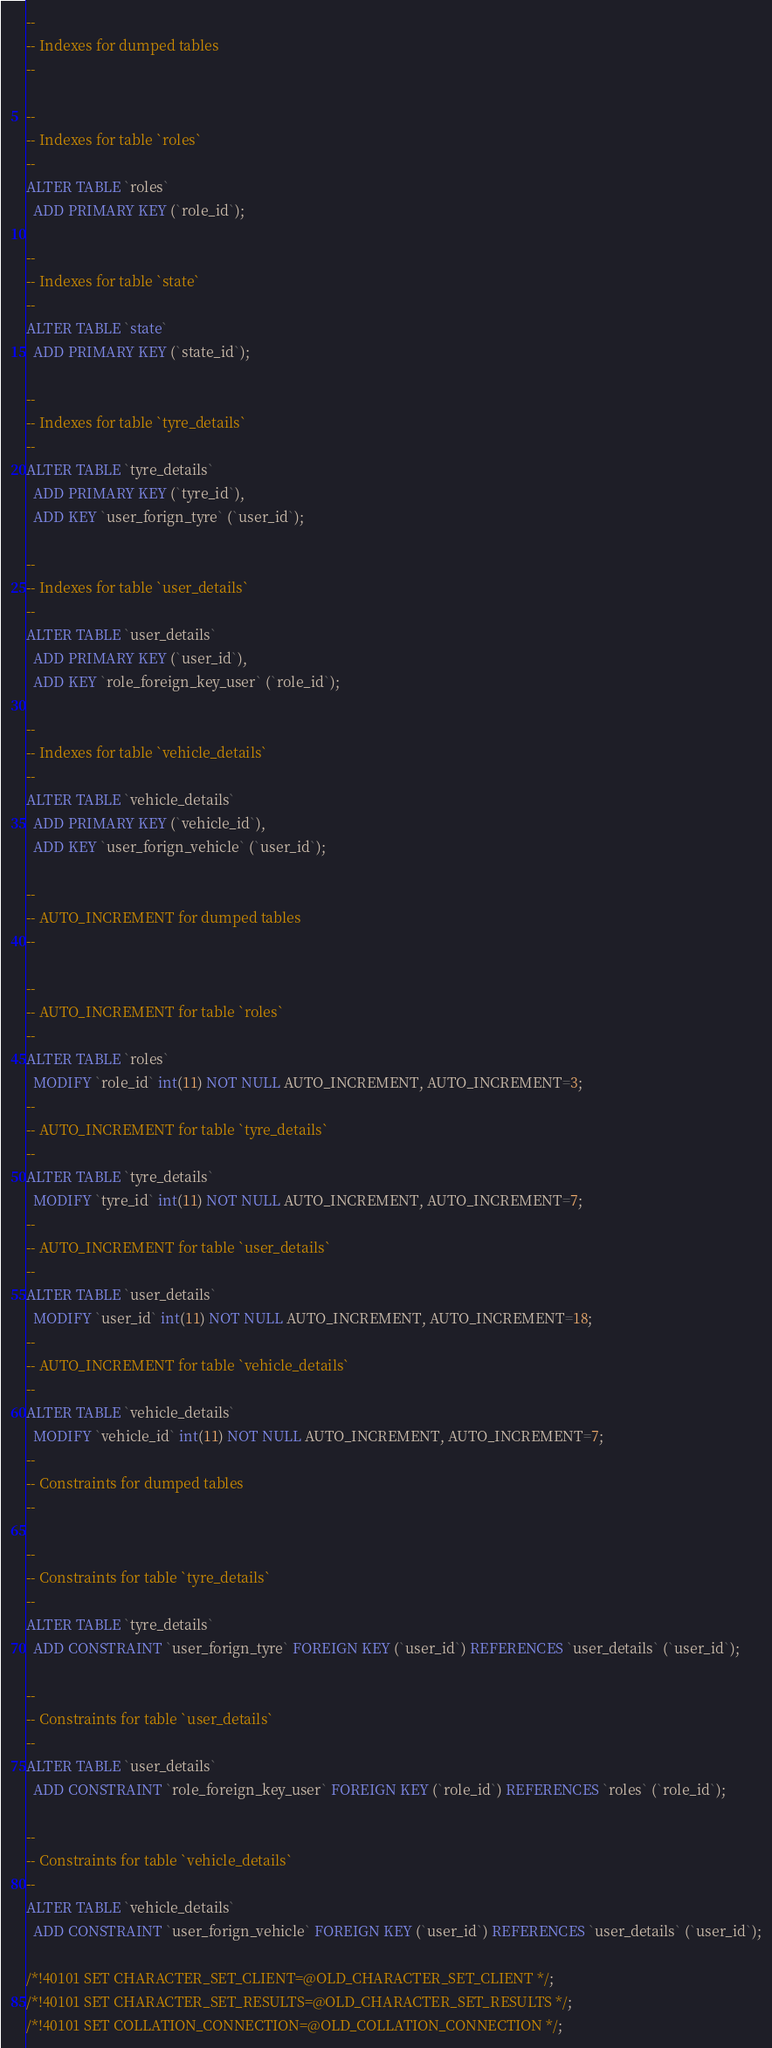Convert code to text. <code><loc_0><loc_0><loc_500><loc_500><_SQL_>--
-- Indexes for dumped tables
--

--
-- Indexes for table `roles`
--
ALTER TABLE `roles`
  ADD PRIMARY KEY (`role_id`);

--
-- Indexes for table `state`
--
ALTER TABLE `state`
  ADD PRIMARY KEY (`state_id`);

--
-- Indexes for table `tyre_details`
--
ALTER TABLE `tyre_details`
  ADD PRIMARY KEY (`tyre_id`),
  ADD KEY `user_forign_tyre` (`user_id`);

--
-- Indexes for table `user_details`
--
ALTER TABLE `user_details`
  ADD PRIMARY KEY (`user_id`),
  ADD KEY `role_foreign_key_user` (`role_id`);

--
-- Indexes for table `vehicle_details`
--
ALTER TABLE `vehicle_details`
  ADD PRIMARY KEY (`vehicle_id`),
  ADD KEY `user_forign_vehicle` (`user_id`);

--
-- AUTO_INCREMENT for dumped tables
--

--
-- AUTO_INCREMENT for table `roles`
--
ALTER TABLE `roles`
  MODIFY `role_id` int(11) NOT NULL AUTO_INCREMENT, AUTO_INCREMENT=3;
--
-- AUTO_INCREMENT for table `tyre_details`
--
ALTER TABLE `tyre_details`
  MODIFY `tyre_id` int(11) NOT NULL AUTO_INCREMENT, AUTO_INCREMENT=7;
--
-- AUTO_INCREMENT for table `user_details`
--
ALTER TABLE `user_details`
  MODIFY `user_id` int(11) NOT NULL AUTO_INCREMENT, AUTO_INCREMENT=18;
--
-- AUTO_INCREMENT for table `vehicle_details`
--
ALTER TABLE `vehicle_details`
  MODIFY `vehicle_id` int(11) NOT NULL AUTO_INCREMENT, AUTO_INCREMENT=7;
--
-- Constraints for dumped tables
--

--
-- Constraints for table `tyre_details`
--
ALTER TABLE `tyre_details`
  ADD CONSTRAINT `user_forign_tyre` FOREIGN KEY (`user_id`) REFERENCES `user_details` (`user_id`);

--
-- Constraints for table `user_details`
--
ALTER TABLE `user_details`
  ADD CONSTRAINT `role_foreign_key_user` FOREIGN KEY (`role_id`) REFERENCES `roles` (`role_id`);

--
-- Constraints for table `vehicle_details`
--
ALTER TABLE `vehicle_details`
  ADD CONSTRAINT `user_forign_vehicle` FOREIGN KEY (`user_id`) REFERENCES `user_details` (`user_id`);

/*!40101 SET CHARACTER_SET_CLIENT=@OLD_CHARACTER_SET_CLIENT */;
/*!40101 SET CHARACTER_SET_RESULTS=@OLD_CHARACTER_SET_RESULTS */;
/*!40101 SET COLLATION_CONNECTION=@OLD_COLLATION_CONNECTION */;
</code> 